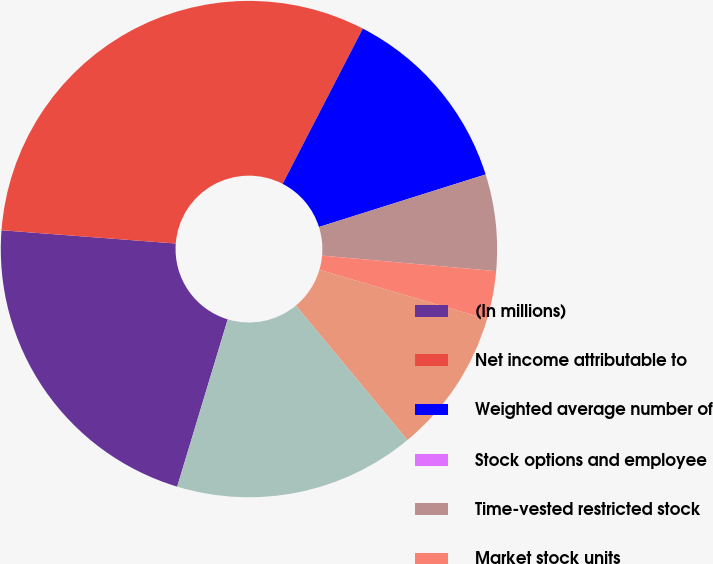Convert chart. <chart><loc_0><loc_0><loc_500><loc_500><pie_chart><fcel>(In millions)<fcel>Net income attributable to<fcel>Weighted average number of<fcel>Stock options and employee<fcel>Time-vested restricted stock<fcel>Market stock units<fcel>Dilutive potential common<fcel>Shares used in calculating<nl><fcel>21.54%<fcel>31.38%<fcel>12.55%<fcel>0.0%<fcel>6.28%<fcel>3.14%<fcel>9.42%<fcel>15.69%<nl></chart> 